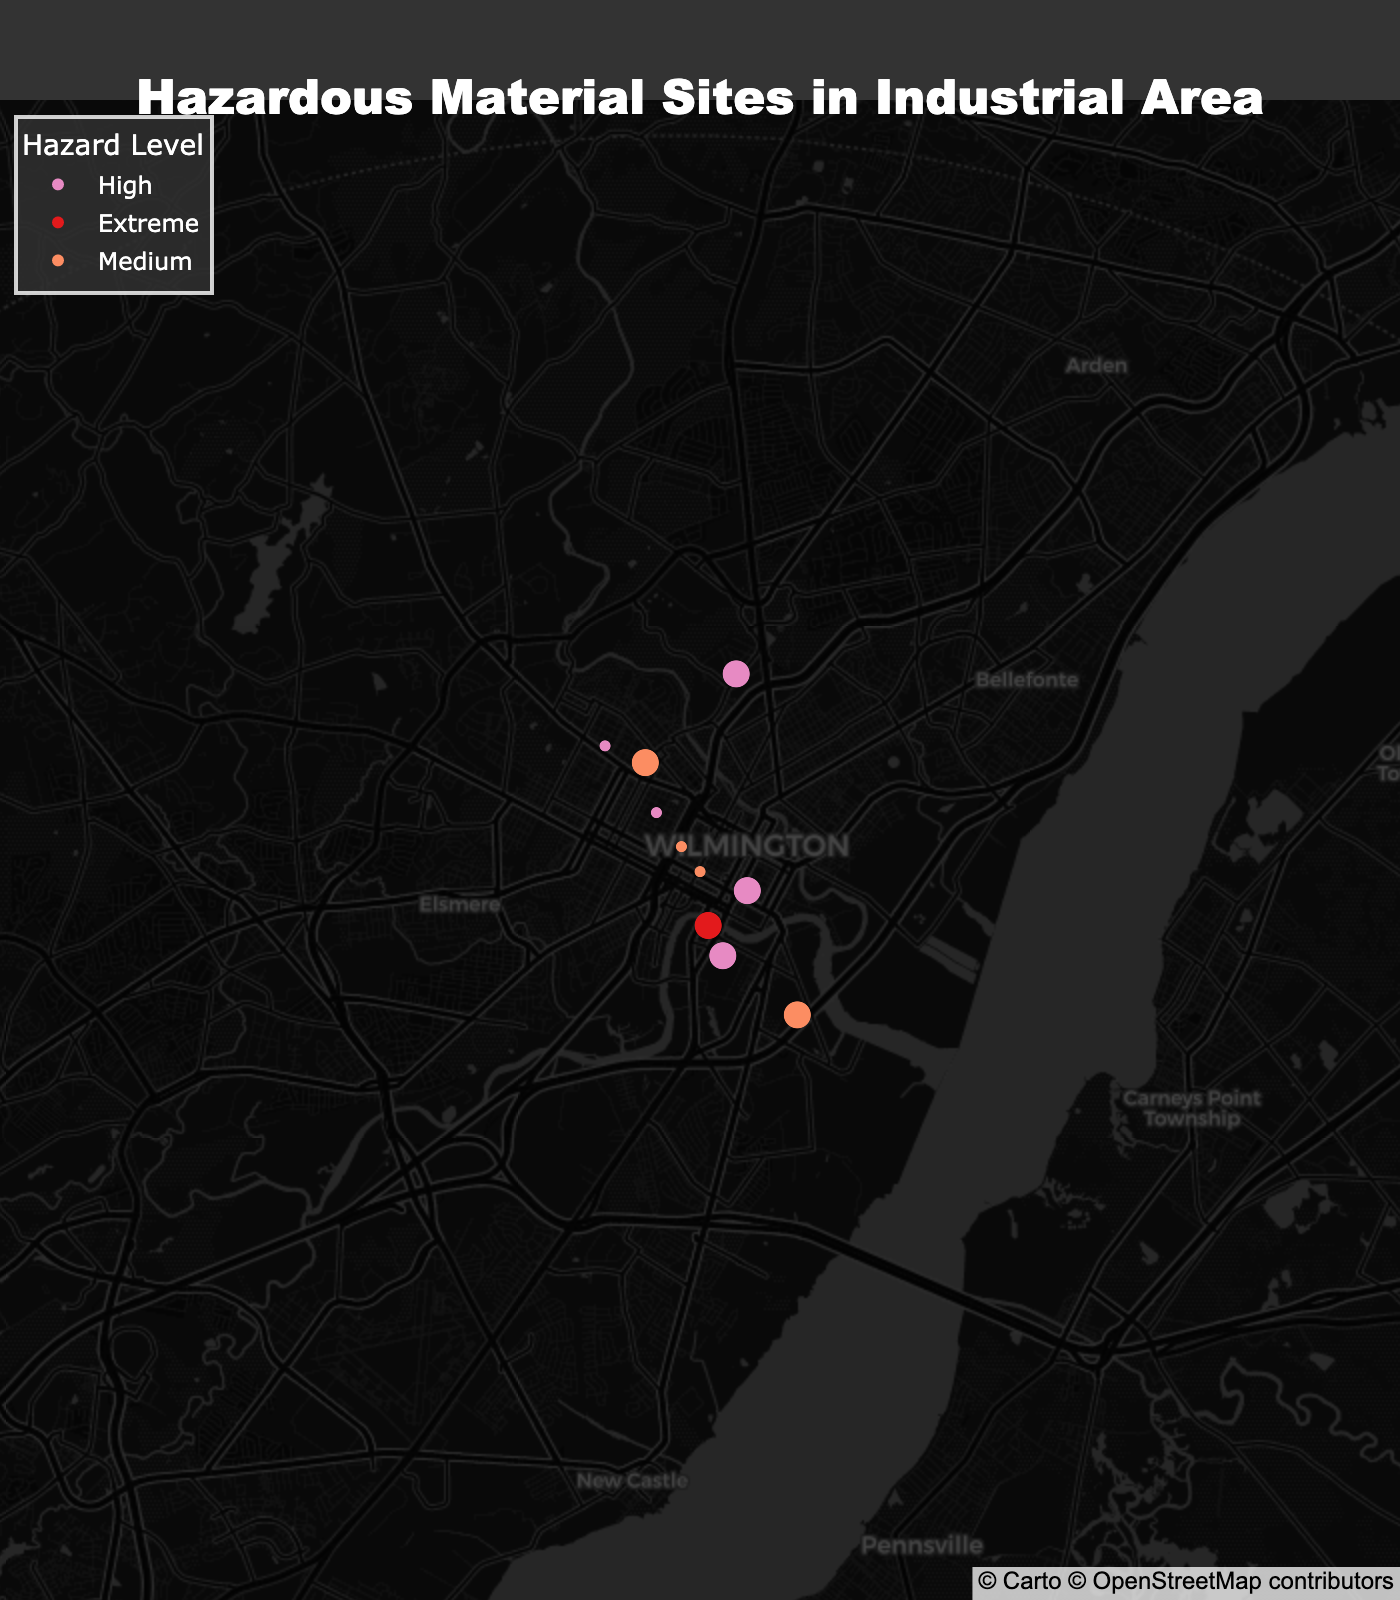How many sites are categorized as 'Storage'? By looking at the visual representation of dots on the map marked as 'Storage', count the number of such dots to determine the total.
Answer: 6 What is the average latitude of the transportation sites? Note the latitudes for all transportation sites, sum them, and divide by the number of transportation sites. The latitudes are 39.7456, 39.7589, 39.7501, and 39.7423. So the average is (39.7456 + 39.7589 + 39.7501 + 39.7423) / 4.
Answer: 39.749225 Which site has the highest hazard level? Identify the site with the 'Extreme' hazard level. In this case, it’s marked clearly with the specified color and level.
Answer: Delaware City Refinery Are there more high-hazard storage sites or high-hazard transportation sites? Count the number of sites rated as 'High' for both storage and transportation types. For storage, the count is 3 (DuPont Experimental Station, Croda Atlas Point, Chemours Experimental Station). For transportation, it is 2 (I-495 Chemical Corridor, CSX Wilmington Rail Yard).
Answer: Storage Which sectors have medium hazard levels? Look for sites marked with the medium hazard color and identify their labels. The names include Port of Wilmington (Transportation), FMC BioPolymer (Storage), Delaware Memorial Bridge (Transportation), and Air Liquide Industrial Gases (Storage).
Answer: Both sectors What is the northernmost storage site and its hazard level? Compare the latitudes of all storage sites and identify the highest latitude site, then note its hazard level. The northernmost storage site is DuPont Experimental Station with a latitude of 39.7684. Its hazard level is High.
Answer: DuPont Experimental Station, High Out of the 'High' hazard level sites, which one is the furthest south? Identify all the sites with 'High' hazard levels and compare their latitudes, picking the one with the lowest latitude. This site is Chemours Experimental Station at latitude 39.7312.
Answer: Chemours Experimental Station What is the common characteristic of the sites with 'Medium' hazard levels in terms of their type? Identify the types of all the sites with 'Medium' hazard levels. They are equally split between Storage (FMC BioPolymer, Air Liquide Industrial Gases) and Transportation (Port of Wilmington, Delaware Memorial Bridge).
Answer: Split between Storage and Transportation 